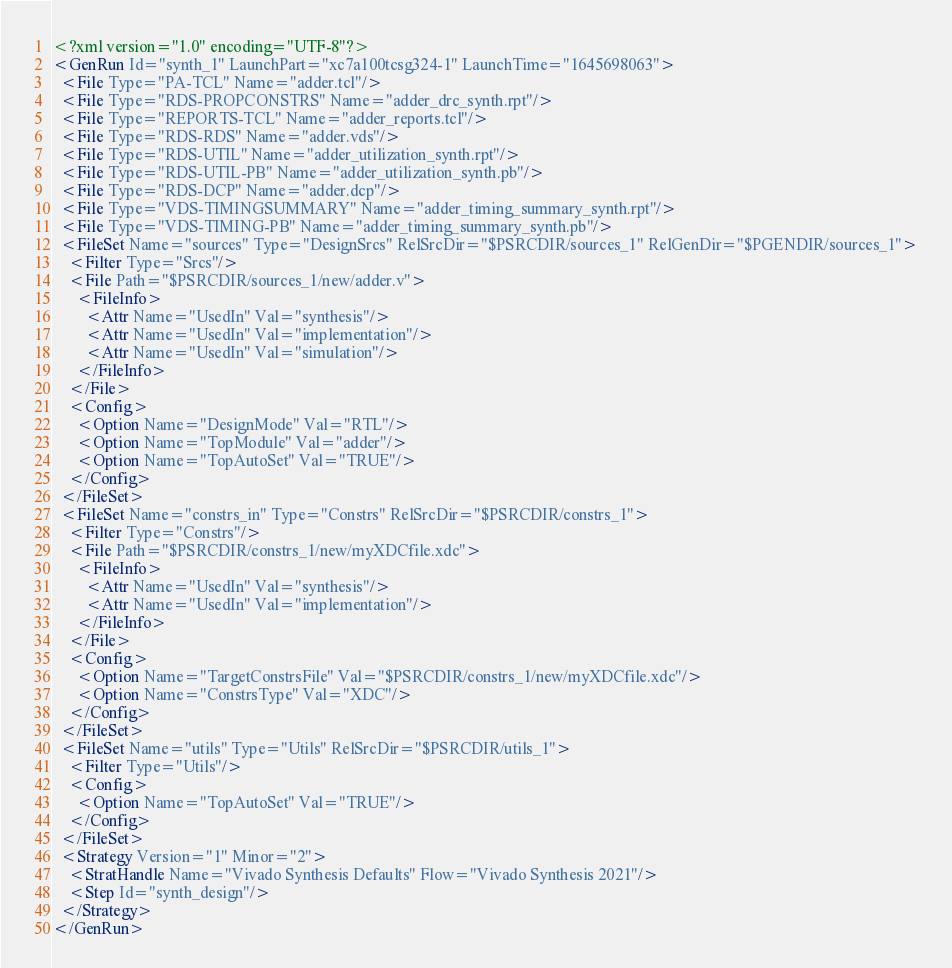<code> <loc_0><loc_0><loc_500><loc_500><_XML_><?xml version="1.0" encoding="UTF-8"?>
<GenRun Id="synth_1" LaunchPart="xc7a100tcsg324-1" LaunchTime="1645698063">
  <File Type="PA-TCL" Name="adder.tcl"/>
  <File Type="RDS-PROPCONSTRS" Name="adder_drc_synth.rpt"/>
  <File Type="REPORTS-TCL" Name="adder_reports.tcl"/>
  <File Type="RDS-RDS" Name="adder.vds"/>
  <File Type="RDS-UTIL" Name="adder_utilization_synth.rpt"/>
  <File Type="RDS-UTIL-PB" Name="adder_utilization_synth.pb"/>
  <File Type="RDS-DCP" Name="adder.dcp"/>
  <File Type="VDS-TIMINGSUMMARY" Name="adder_timing_summary_synth.rpt"/>
  <File Type="VDS-TIMING-PB" Name="adder_timing_summary_synth.pb"/>
  <FileSet Name="sources" Type="DesignSrcs" RelSrcDir="$PSRCDIR/sources_1" RelGenDir="$PGENDIR/sources_1">
    <Filter Type="Srcs"/>
    <File Path="$PSRCDIR/sources_1/new/adder.v">
      <FileInfo>
        <Attr Name="UsedIn" Val="synthesis"/>
        <Attr Name="UsedIn" Val="implementation"/>
        <Attr Name="UsedIn" Val="simulation"/>
      </FileInfo>
    </File>
    <Config>
      <Option Name="DesignMode" Val="RTL"/>
      <Option Name="TopModule" Val="adder"/>
      <Option Name="TopAutoSet" Val="TRUE"/>
    </Config>
  </FileSet>
  <FileSet Name="constrs_in" Type="Constrs" RelSrcDir="$PSRCDIR/constrs_1">
    <Filter Type="Constrs"/>
    <File Path="$PSRCDIR/constrs_1/new/myXDCfile.xdc">
      <FileInfo>
        <Attr Name="UsedIn" Val="synthesis"/>
        <Attr Name="UsedIn" Val="implementation"/>
      </FileInfo>
    </File>
    <Config>
      <Option Name="TargetConstrsFile" Val="$PSRCDIR/constrs_1/new/myXDCfile.xdc"/>
      <Option Name="ConstrsType" Val="XDC"/>
    </Config>
  </FileSet>
  <FileSet Name="utils" Type="Utils" RelSrcDir="$PSRCDIR/utils_1">
    <Filter Type="Utils"/>
    <Config>
      <Option Name="TopAutoSet" Val="TRUE"/>
    </Config>
  </FileSet>
  <Strategy Version="1" Minor="2">
    <StratHandle Name="Vivado Synthesis Defaults" Flow="Vivado Synthesis 2021"/>
    <Step Id="synth_design"/>
  </Strategy>
</GenRun>
</code> 